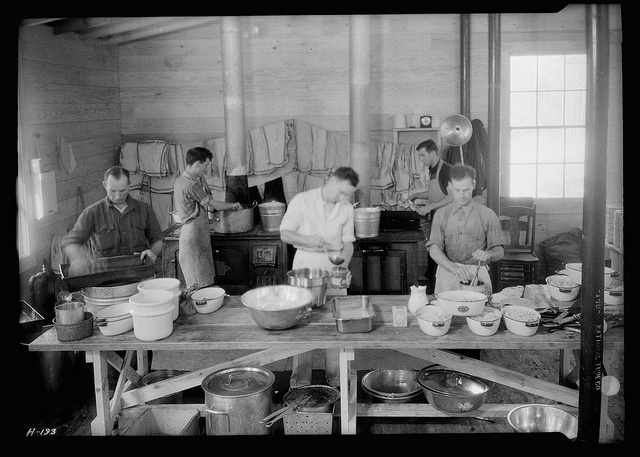Describe the objects in this image and their specific colors. I can see people in black, darkgray, dimgray, and lightgray tones, people in black, gray, and lightgray tones, people in black, darkgray, lightgray, and gray tones, people in black, gray, darkgray, and lightgray tones, and chair in black and gray tones in this image. 